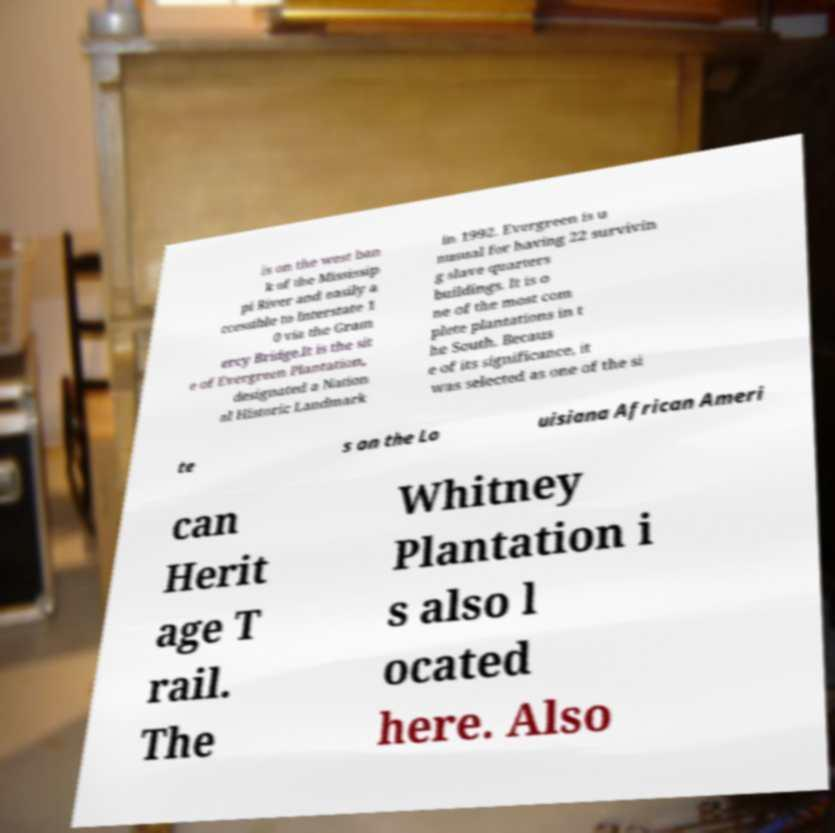Can you read and provide the text displayed in the image?This photo seems to have some interesting text. Can you extract and type it out for me? is on the west ban k of the Mississip pi River and easily a ccessible to Interstate 1 0 via the Gram ercy Bridge.It is the sit e of Evergreen Plantation, designated a Nation al Historic Landmark in 1992. Evergreen is u nusual for having 22 survivin g slave quarters buildings. It is o ne of the most com plete plantations in t he South. Becaus e of its significance, it was selected as one of the si te s on the Lo uisiana African Ameri can Herit age T rail. The Whitney Plantation i s also l ocated here. Also 